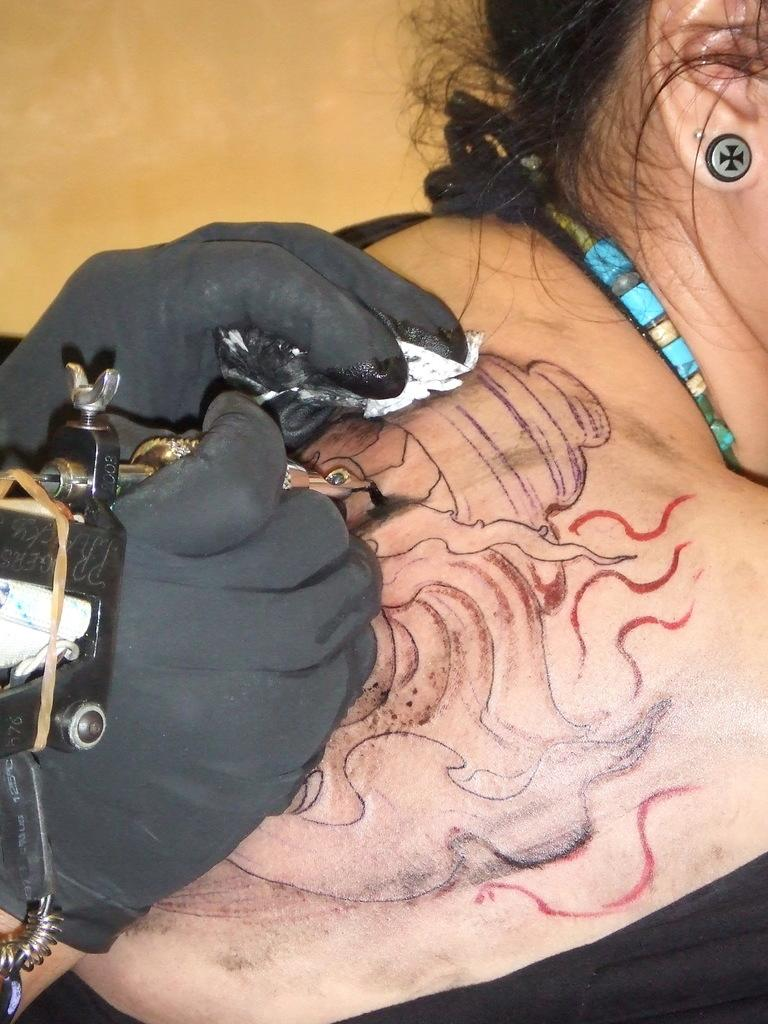What is the main subject of the image? There is a woman in the image. Can you describe any features or accessories the woman has? The woman has a tattoo on her back, a stud in her ear, and an ornament in her neck. What else can be seen in the image? There is a tattoo machine in the image. What type of drink is the woman holding in the image? There is no drink visible in the image; the woman is not holding anything. Can you tell me how many birds are present in the image? There are no birds present in the image. 